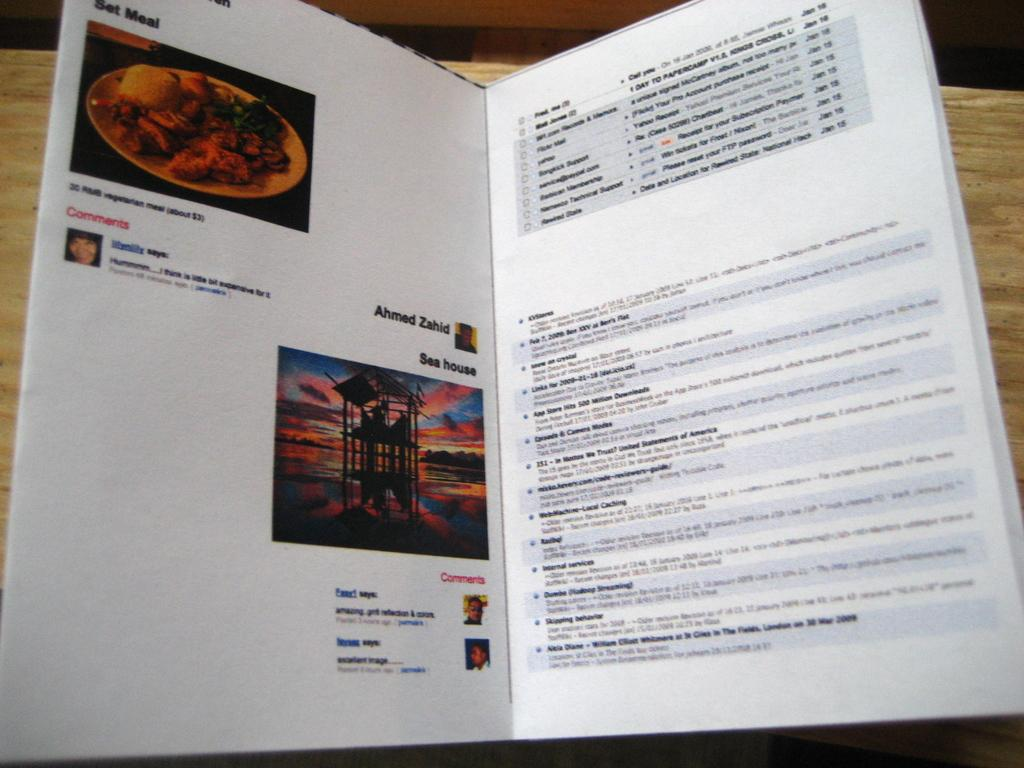What object is on the table in the image? There is a book on the table in the image. What type of content is in the book? The book contains photographs and text. What is the plot of the book in the image? The provided facts do not mention a plot, as the book contains photographs and text. Therefore, it is not possible to determine the plot from the image. 